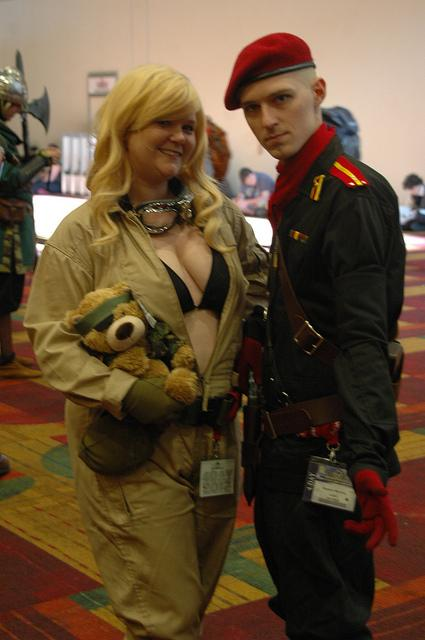What clothes are the people wearing?

Choices:
A) uniform
B) costume
C) underwear
D) pajamas costume 